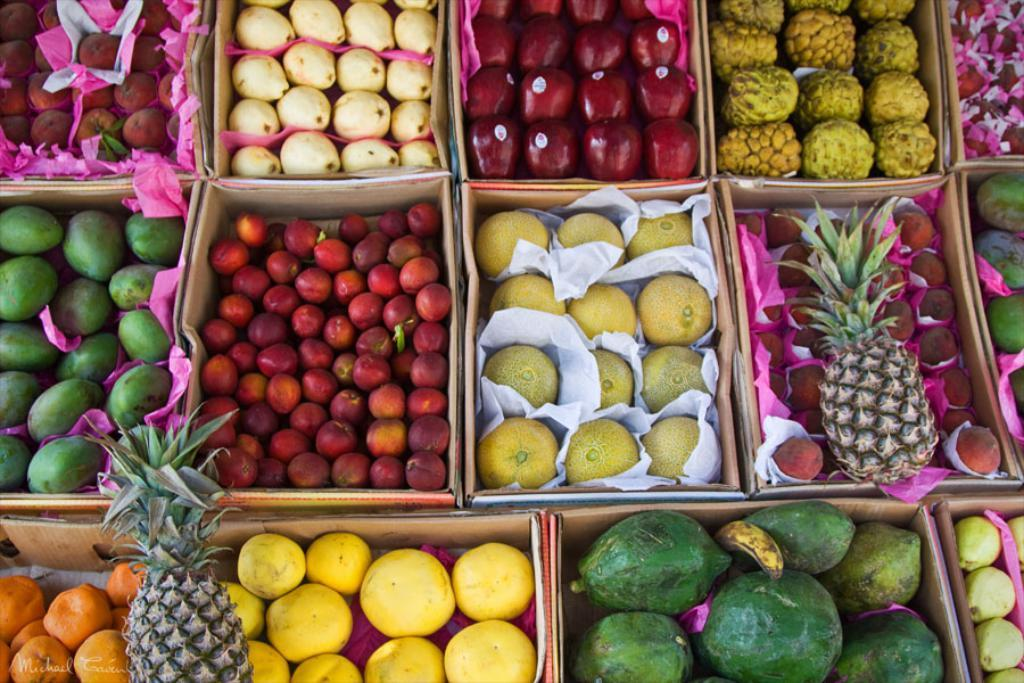What is inside the boxes in the image? There are fruits in the boxes in the image. How can you identify the type of fruit in the boxes? There are stickers on the fruits, which may indicate their variety or origin. What else can be seen in the image besides the fruits? There are papers in the image. What information can be found towards the bottom of the image? There is text visible towards the bottom of the image. Can you see any sand or a plough in the image? No, there is no sand or plough present in the image. Is there a rat visible in the image? No, there is no rat present in the image. 